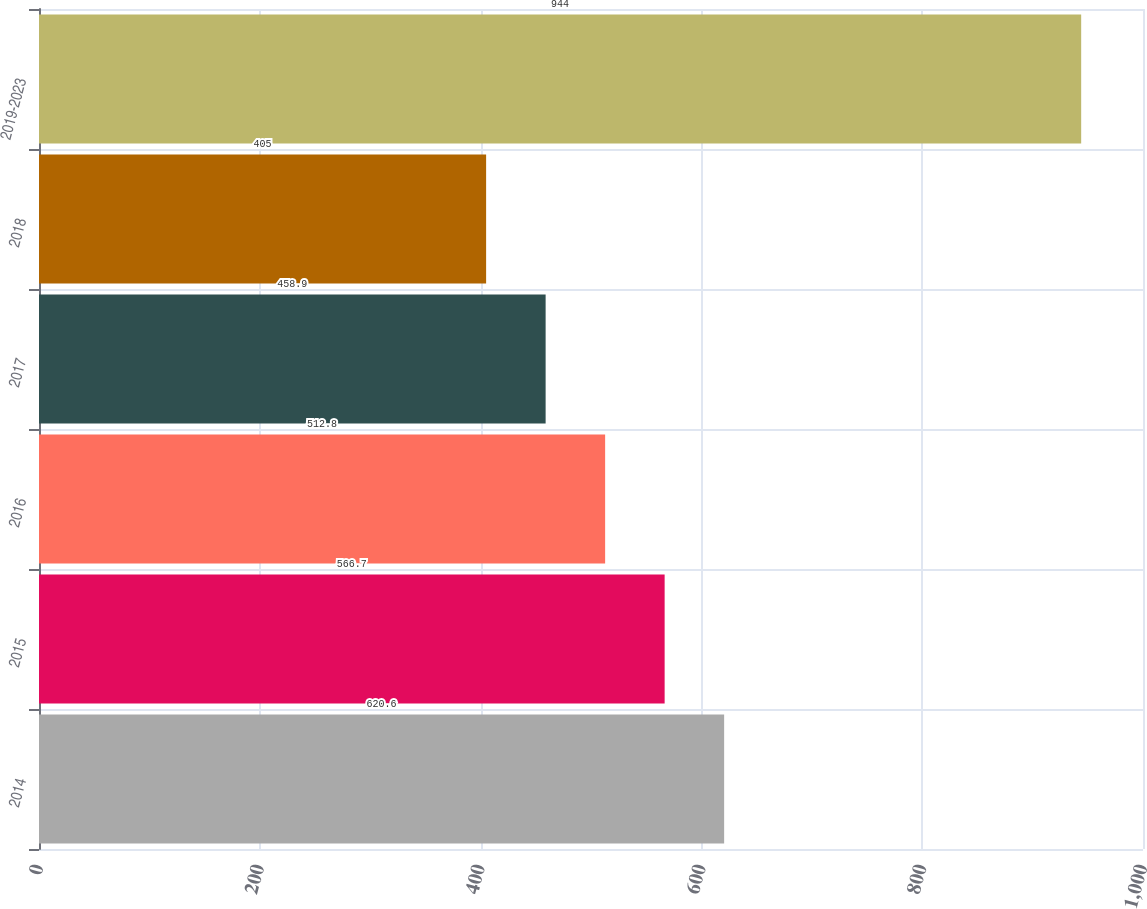Convert chart. <chart><loc_0><loc_0><loc_500><loc_500><bar_chart><fcel>2014<fcel>2015<fcel>2016<fcel>2017<fcel>2018<fcel>2019-2023<nl><fcel>620.6<fcel>566.7<fcel>512.8<fcel>458.9<fcel>405<fcel>944<nl></chart> 